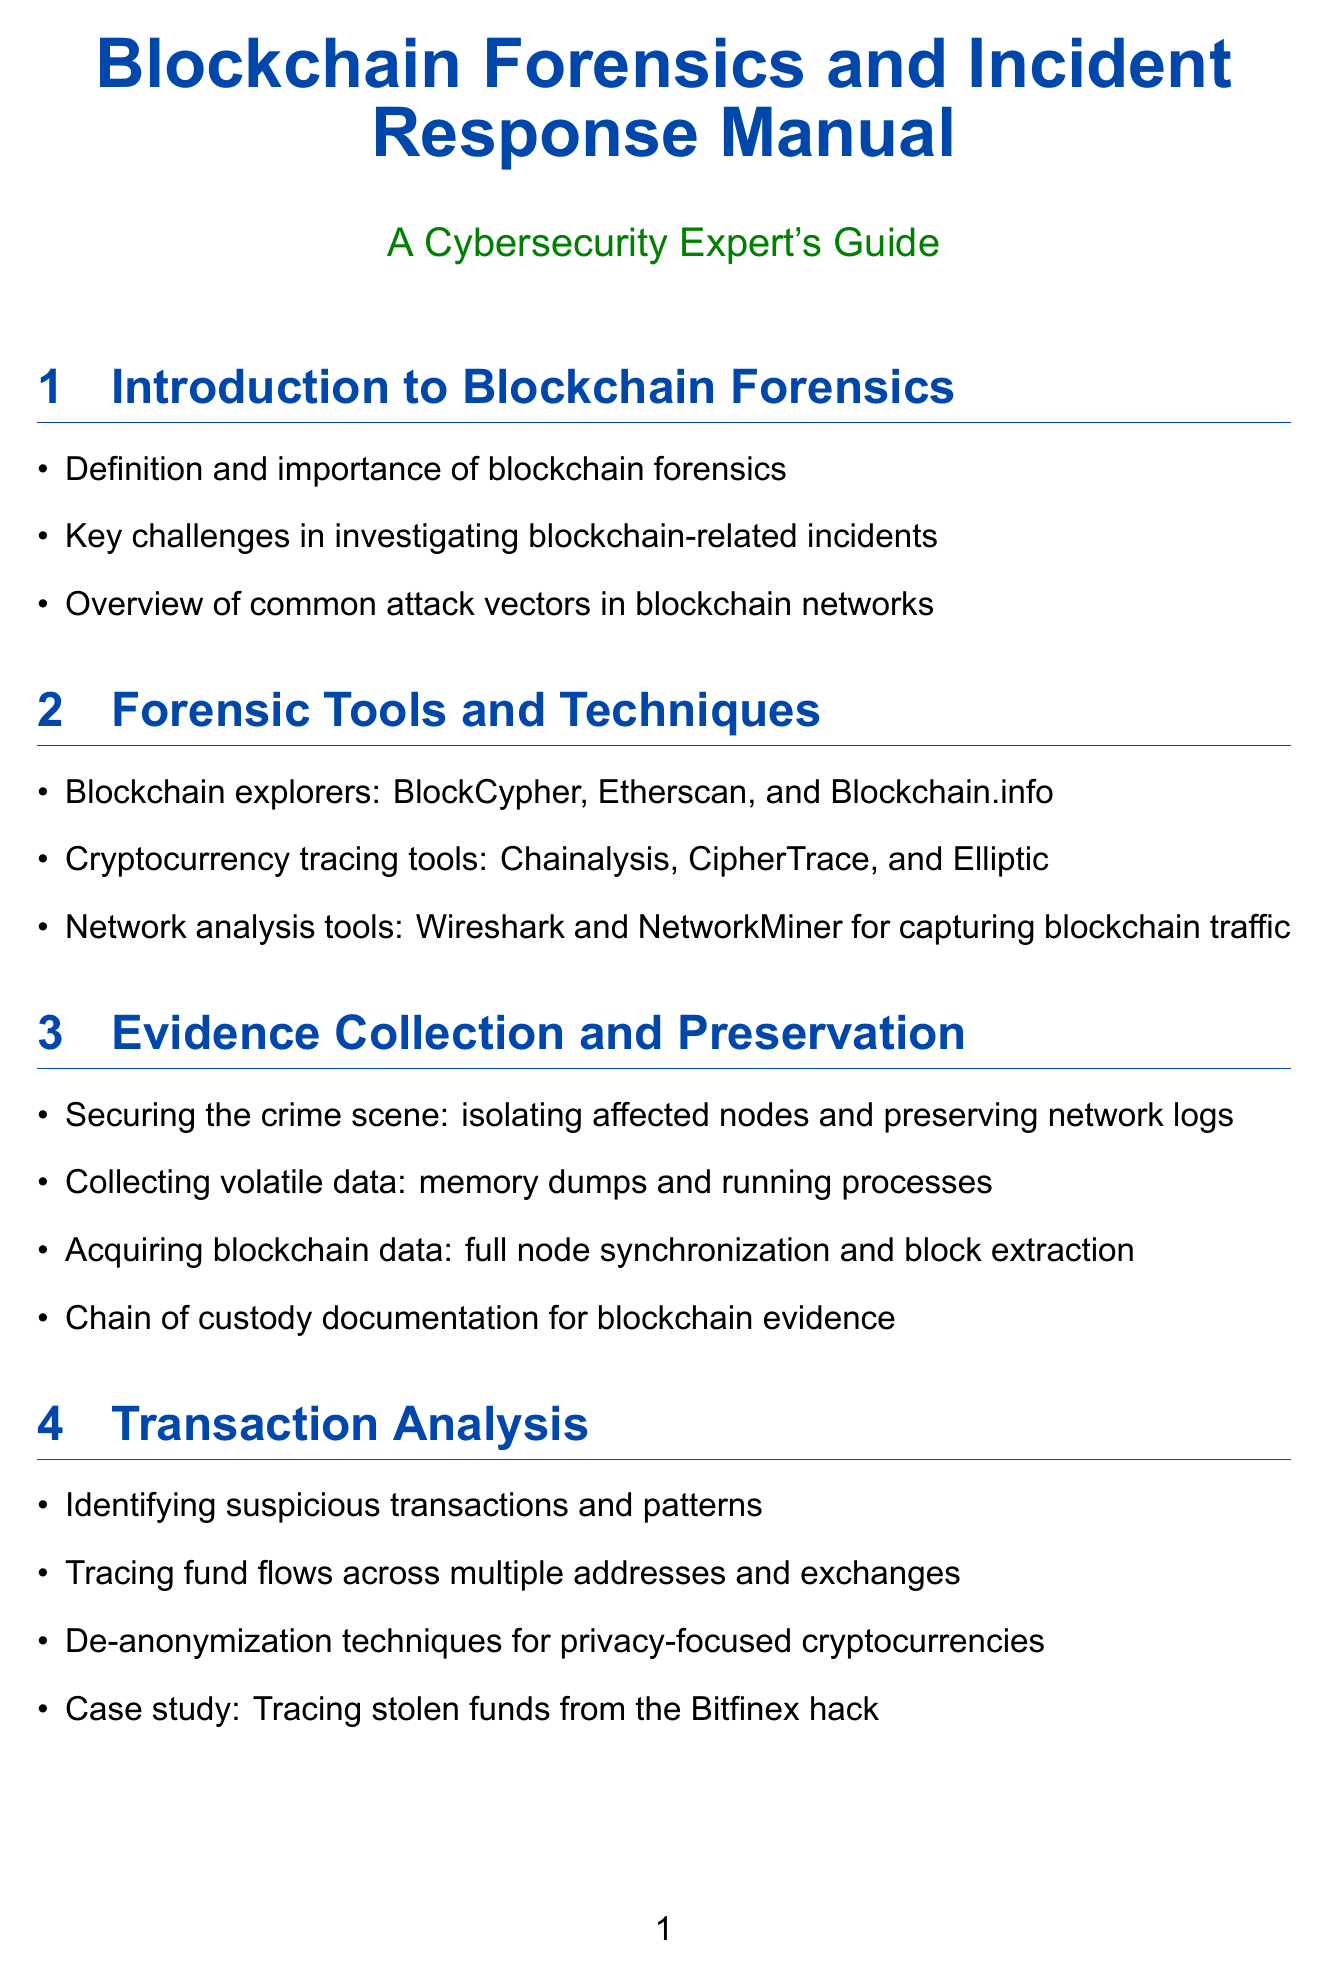What is the title of the manual? The title is provided at the beginning of the document.
Answer: Blockchain Forensics and Incident Response Manual What is one example of a blockchain explorer mentioned? The document lists specific examples in the section about forensic tools.
Answer: BlockCypher What is the purpose of documenting the chain of custody? It refers to the importance of maintaining evidence in investigations, as highlighted in the evidence collection section.
Answer: Blockchain evidence Which tool is used for static analysis of smart contracts? The manual includes specific tools for different analyses in the auditing section.
Answer: Mythril What incident does the case study in transaction analysis focus on? The case studies section references specific incidents related to blockchain investigations.
Answer: Bitfinex hack Which two data protection regulations are mentioned in the legal considerations? The document specifies compliance regulations in the relevant section.
Answer: GDPR, CCPA What type of wallet is recommended for enhancing blockchain security? The best practices section includes various recommendations for security measures.
Answer: Multi-signature wallets What is one future trend in blockchain forensics mentioned? The manual discusses potential future developments in its last section.
Answer: AI-powered blockchain analysis How many sections are there in the manual? The total number of sections is counted based on the table of contents.
Answer: Ten 